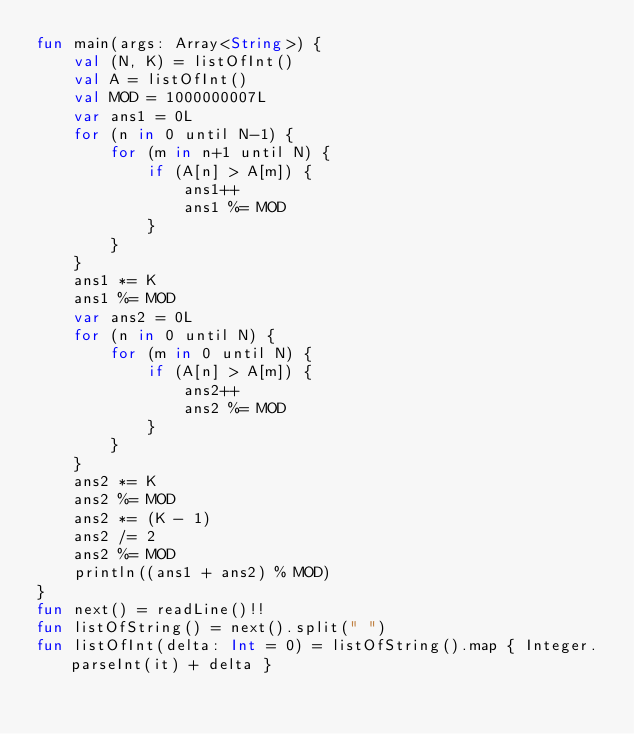<code> <loc_0><loc_0><loc_500><loc_500><_Kotlin_>fun main(args: Array<String>) {
    val (N, K) = listOfInt()
    val A = listOfInt()
    val MOD = 1000000007L
    var ans1 = 0L
    for (n in 0 until N-1) {
        for (m in n+1 until N) {
            if (A[n] > A[m]) {
                ans1++
                ans1 %= MOD
            }
        }
    }
    ans1 *= K
    ans1 %= MOD
    var ans2 = 0L
    for (n in 0 until N) {
        for (m in 0 until N) {
            if (A[n] > A[m]) {
                ans2++
                ans2 %= MOD
            }
        }
    }
    ans2 *= K
    ans2 %= MOD
    ans2 *= (K - 1)
    ans2 /= 2
    ans2 %= MOD
    println((ans1 + ans2) % MOD)
}
fun next() = readLine()!!
fun listOfString() = next().split(" ")
fun listOfInt(delta: Int = 0) = listOfString().map { Integer.parseInt(it) + delta }
</code> 